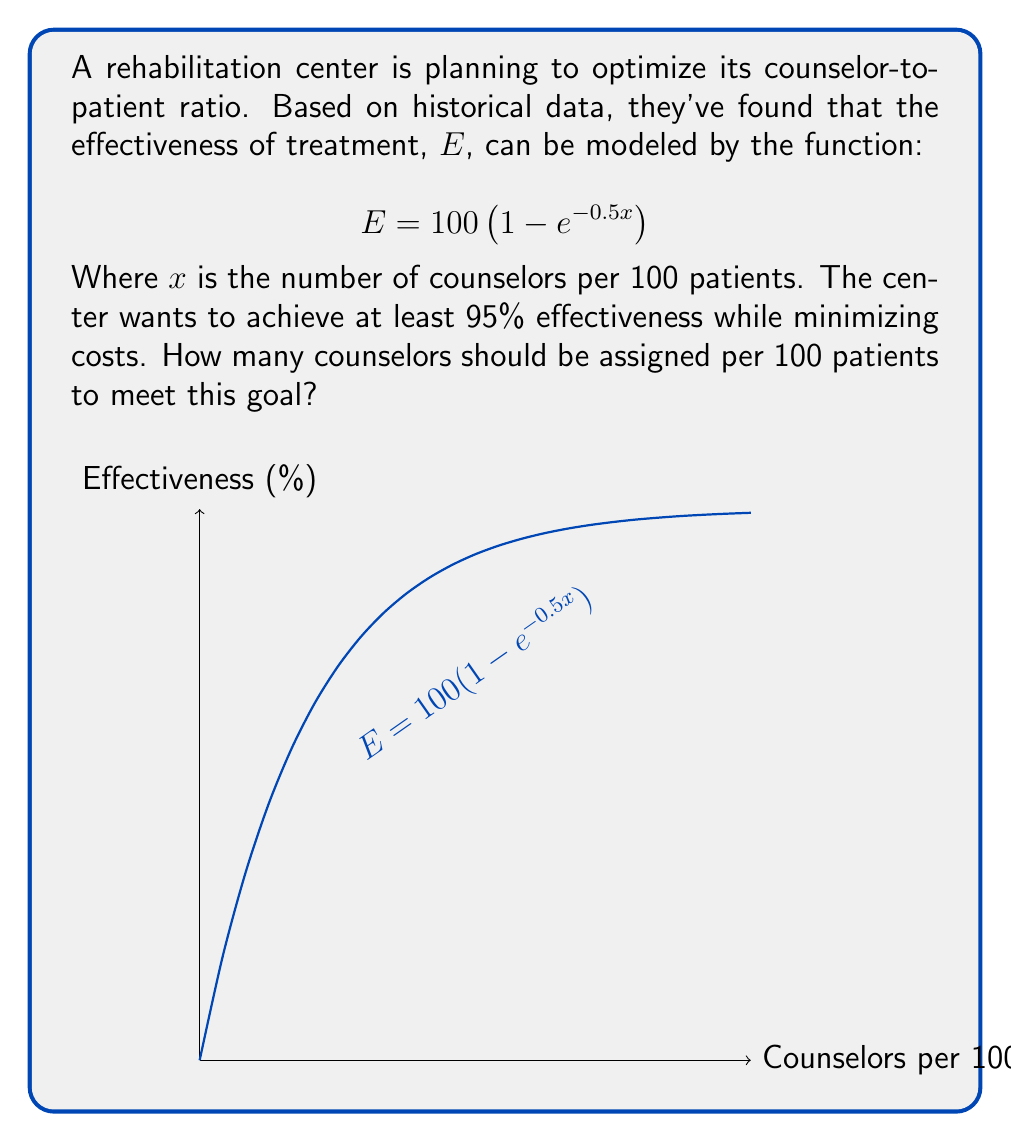Teach me how to tackle this problem. Let's approach this step-by-step:

1) We need to solve the equation:
   $$ 95 = 100 \left(1 - e^{-0.5x}\right) $$

2) Divide both sides by 100:
   $$ 0.95 = 1 - e^{-0.5x} $$

3) Subtract both sides from 1:
   $$ 0.05 = e^{-0.5x} $$

4) Take the natural log of both sides:
   $$ \ln(0.05) = -0.5x $$

5) Solve for x:
   $$ x = -\frac{2\ln(0.05)}{1} $$

6) Calculate the value:
   $$ x \approx 5.99 $$

7) Since we can't have a fractional number of counselors, we round up to the nearest whole number.

Therefore, the center should assign 6 counselors per 100 patients to achieve at least 95% effectiveness.
Answer: 6 counselors per 100 patients 